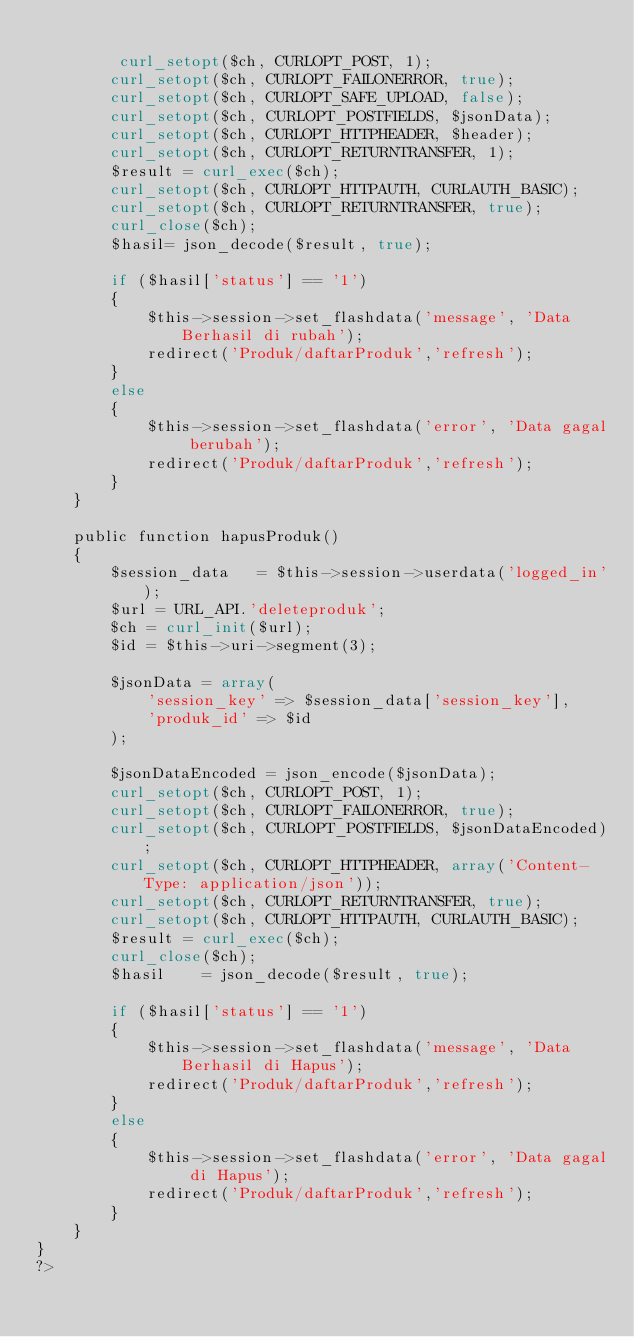<code> <loc_0><loc_0><loc_500><loc_500><_PHP_>        
         curl_setopt($ch, CURLOPT_POST, 1);
        curl_setopt($ch, CURLOPT_FAILONERROR, true);
        curl_setopt($ch, CURLOPT_SAFE_UPLOAD, false);
        curl_setopt($ch, CURLOPT_POSTFIELDS, $jsonData);
        curl_setopt($ch, CURLOPT_HTTPHEADER, $header);
        curl_setopt($ch, CURLOPT_RETURNTRANSFER, 1);
        $result = curl_exec($ch);        
        curl_setopt($ch, CURLOPT_HTTPAUTH, CURLAUTH_BASIC);       
        curl_setopt($ch, CURLOPT_RETURNTRANSFER, true);
        curl_close($ch);
        $hasil= json_decode($result, true);           

        if ($hasil['status'] == '1') 
        {    
            $this->session->set_flashdata('message', 'Data Berhasil di rubah'); 
            redirect('Produk/daftarProduk','refresh');
        }
        else
        {
            $this->session->set_flashdata('error', 'Data gagal berubah');
            redirect('Produk/daftarProduk','refresh');
        }  
    }

    public function hapusProduk()
    {
        $session_data   = $this->session->userdata('logged_in');        
        $url = URL_API.'deleteproduk';
        $ch = curl_init($url);
        $id = $this->uri->segment(3);  
      
        $jsonData = array(           
            'session_key' => $session_data['session_key'],
            'produk_id' => $id
        );     

        $jsonDataEncoded = json_encode($jsonData);
        curl_setopt($ch, CURLOPT_POST, 1);
        curl_setopt($ch, CURLOPT_FAILONERROR, true);
        curl_setopt($ch, CURLOPT_POSTFIELDS, $jsonDataEncoded);
        curl_setopt($ch, CURLOPT_HTTPHEADER, array('Content-Type: application/json'));
        curl_setopt($ch, CURLOPT_RETURNTRANSFER, true);
        curl_setopt($ch, CURLOPT_HTTPAUTH, CURLAUTH_BASIC);     
        $result = curl_exec($ch);
        curl_close($ch);        
        $hasil    = json_decode($result, true);

        if ($hasil['status'] == '1') 
        {    
            $this->session->set_flashdata('message', 'Data Berhasil di Hapus'); 
            redirect('Produk/daftarProduk','refresh');
        }
        else
        {
            $this->session->set_flashdata('error', 'Data gagal di Hapus');
            redirect('Produk/daftarProduk','refresh');
        }  
    }
}
?></code> 